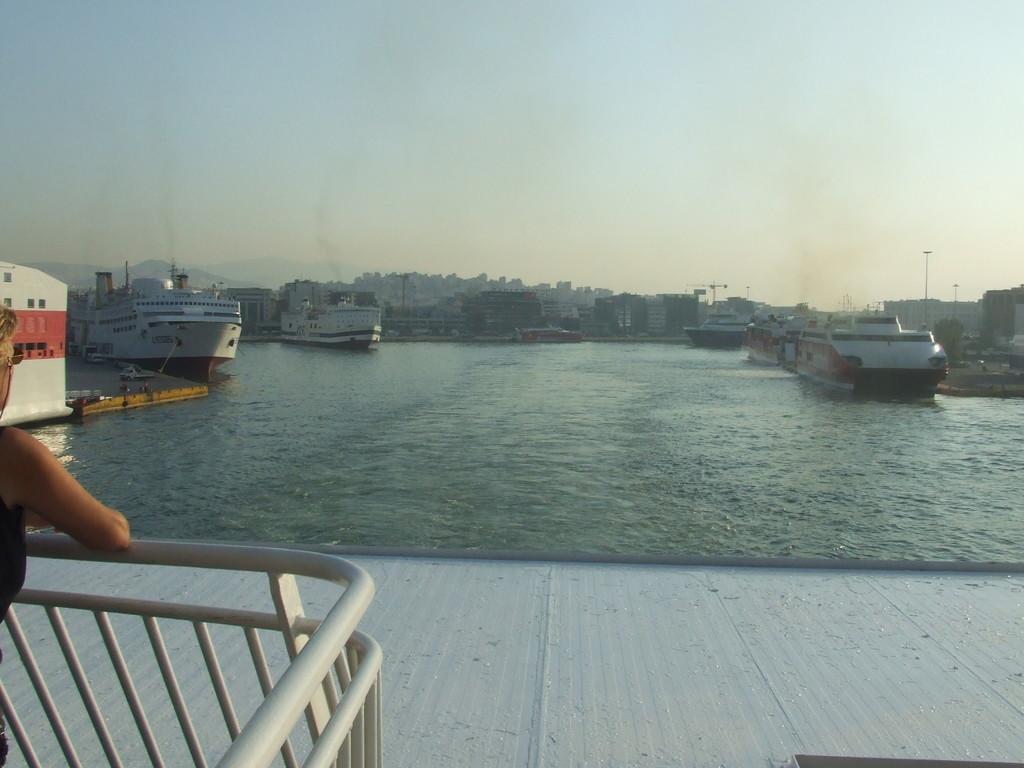Please provide a concise description of this image. In this picture there are ships on the water. On the left side of the image there is a person standing. At the back there are buildings, trees, poles and mountains. At the top there is sky. At the bottom there is water. 